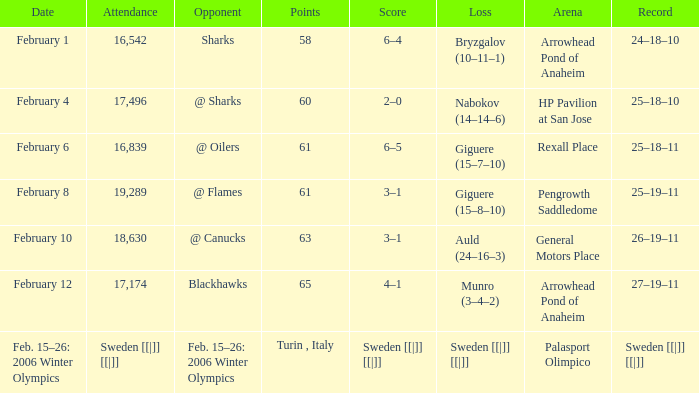What is the record when the score was 2–0? 25–18–10. 